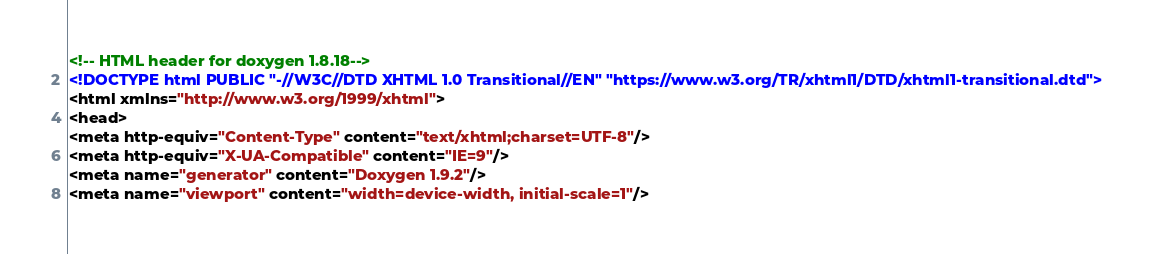Convert code to text. <code><loc_0><loc_0><loc_500><loc_500><_HTML_><!-- HTML header for doxygen 1.8.18-->
<!DOCTYPE html PUBLIC "-//W3C//DTD XHTML 1.0 Transitional//EN" "https://www.w3.org/TR/xhtml1/DTD/xhtml1-transitional.dtd">
<html xmlns="http://www.w3.org/1999/xhtml">
<head>
<meta http-equiv="Content-Type" content="text/xhtml;charset=UTF-8"/>
<meta http-equiv="X-UA-Compatible" content="IE=9"/>
<meta name="generator" content="Doxygen 1.9.2"/>
<meta name="viewport" content="width=device-width, initial-scale=1"/></code> 